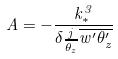<formula> <loc_0><loc_0><loc_500><loc_500>A = - \frac { k _ { * } ^ { 3 } } { \delta \frac { j } { \overline { \theta _ { z } } } \overline { w ^ { \prime } \theta _ { z } ^ { \prime } } }</formula> 